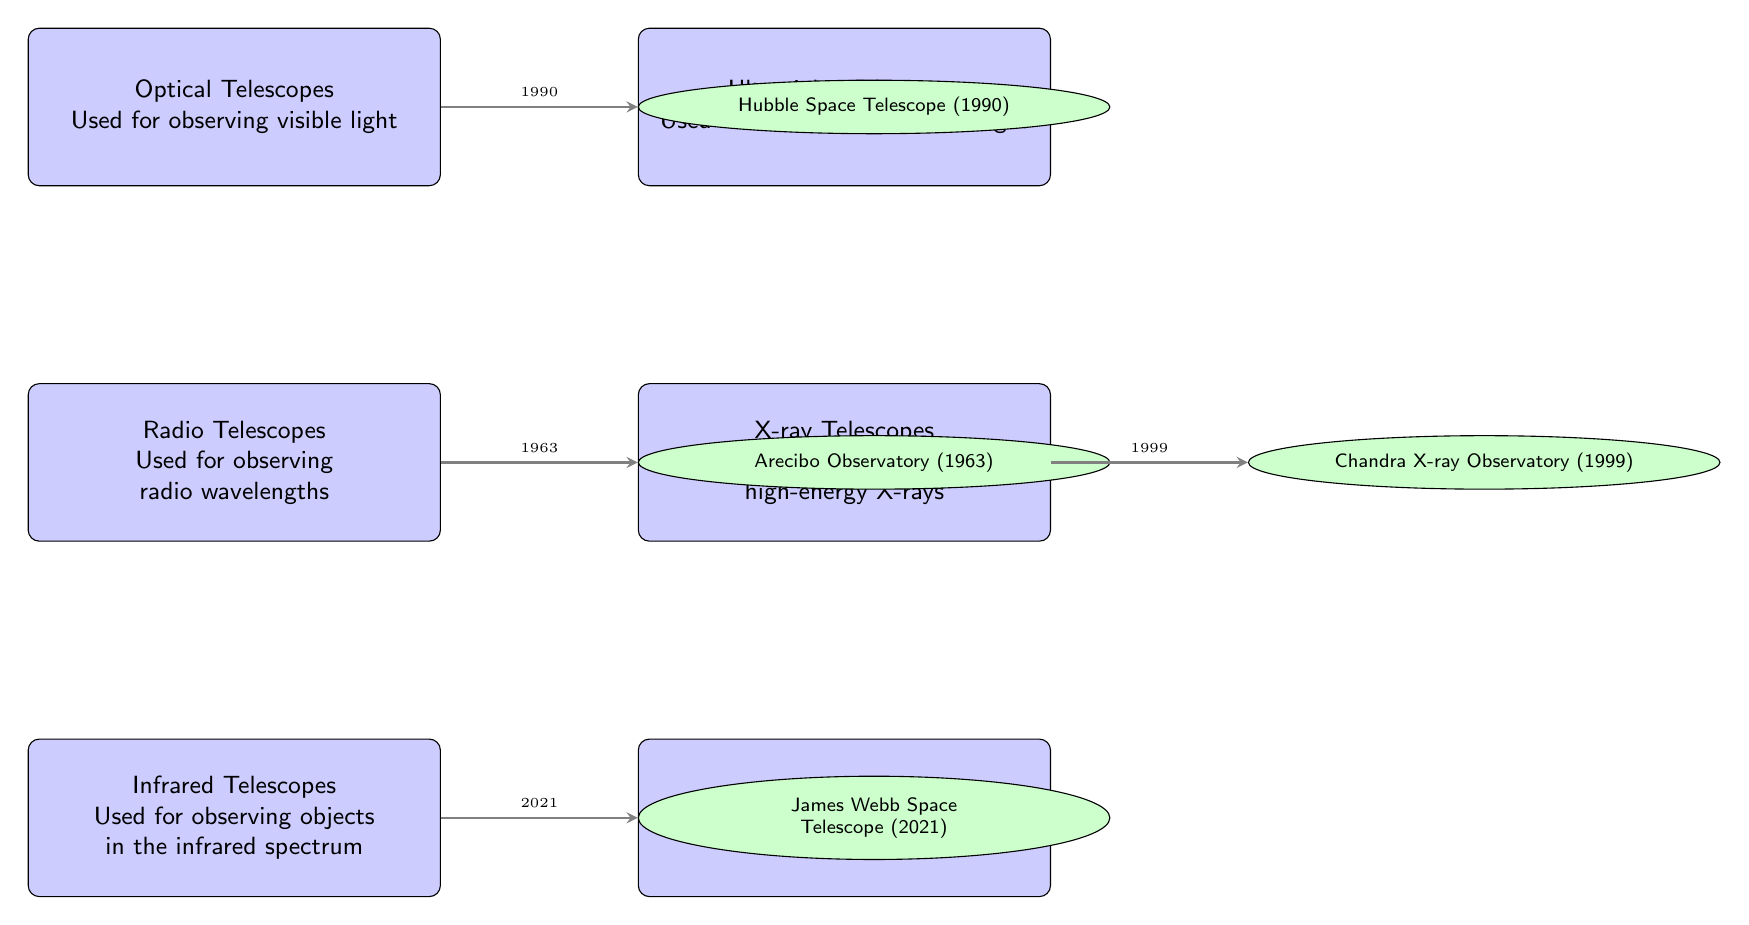What type of telescope is used for observing visible light? The diagram shows that Optical Telescopes are used for observing visible light. This information is written directly on the optical telescope node in the diagram.
Answer: Optical Telescopes What is the name of the telescope associated with observing radio wavelengths? The node representing Radio Telescopes is linked to the Arecibo Observatory. According to the diagram, the name associated with radio wavelengths is Arecibo Observatory.
Answer: Arecibo Observatory How many different types of telescopes are shown in the diagram? By counting the nodes representing telescopes, there are a total of six types indicated in the diagram: Optical, Radio, Infrared, Ultraviolet, X-ray, and Gamma-ray.
Answer: Six Which telescope was launched in 2021? The diagram indicates that the James Webb Space Telescope was launched in 2021, as it is connected to the Infrared Telescopes node.
Answer: James Webb Space Telescope What type of telescope is used for observing high-energy X-rays? The diagram specifies that X-ray Telescopes are used for observing high-energy X-rays, which is noted directly on the X-ray telescope node.
Answer: X-ray Telescopes Which telescope is connected to the optical telescope node? The diagram shows that the Hubble Space Telescope is connected to the optical telescope node, reflecting its connection to observing visible light.
Answer: Hubble Space Telescope What is the order of the telescopes from top to bottom based on their introduction? To find the correct order, we trace from the top of the diagram downwards. The order is Optical (Hubble), Radio (Arecibo), Infrared (Webb), X-ray (Chandra), consistent with the timeline represented by the arrows.
Answer: Optical, Radio, Infrared, X-ray Which telescope technology was introduced first? The diagram indicates that the Arecibo Observatory is linked to the radio telescopes and was introduced first in 1963. This makes it the first one listed in the timeline of telescopes.
Answer: Arecibo Observatory How many examples of telescopes are provided in the diagram? The diagram provides four examples of telescopes: Hubble Space Telescope, Arecibo Observatory, James Webb Space Telescope, and Chandra X-ray Observatory. Counting these gives us four examples in total.
Answer: Four 